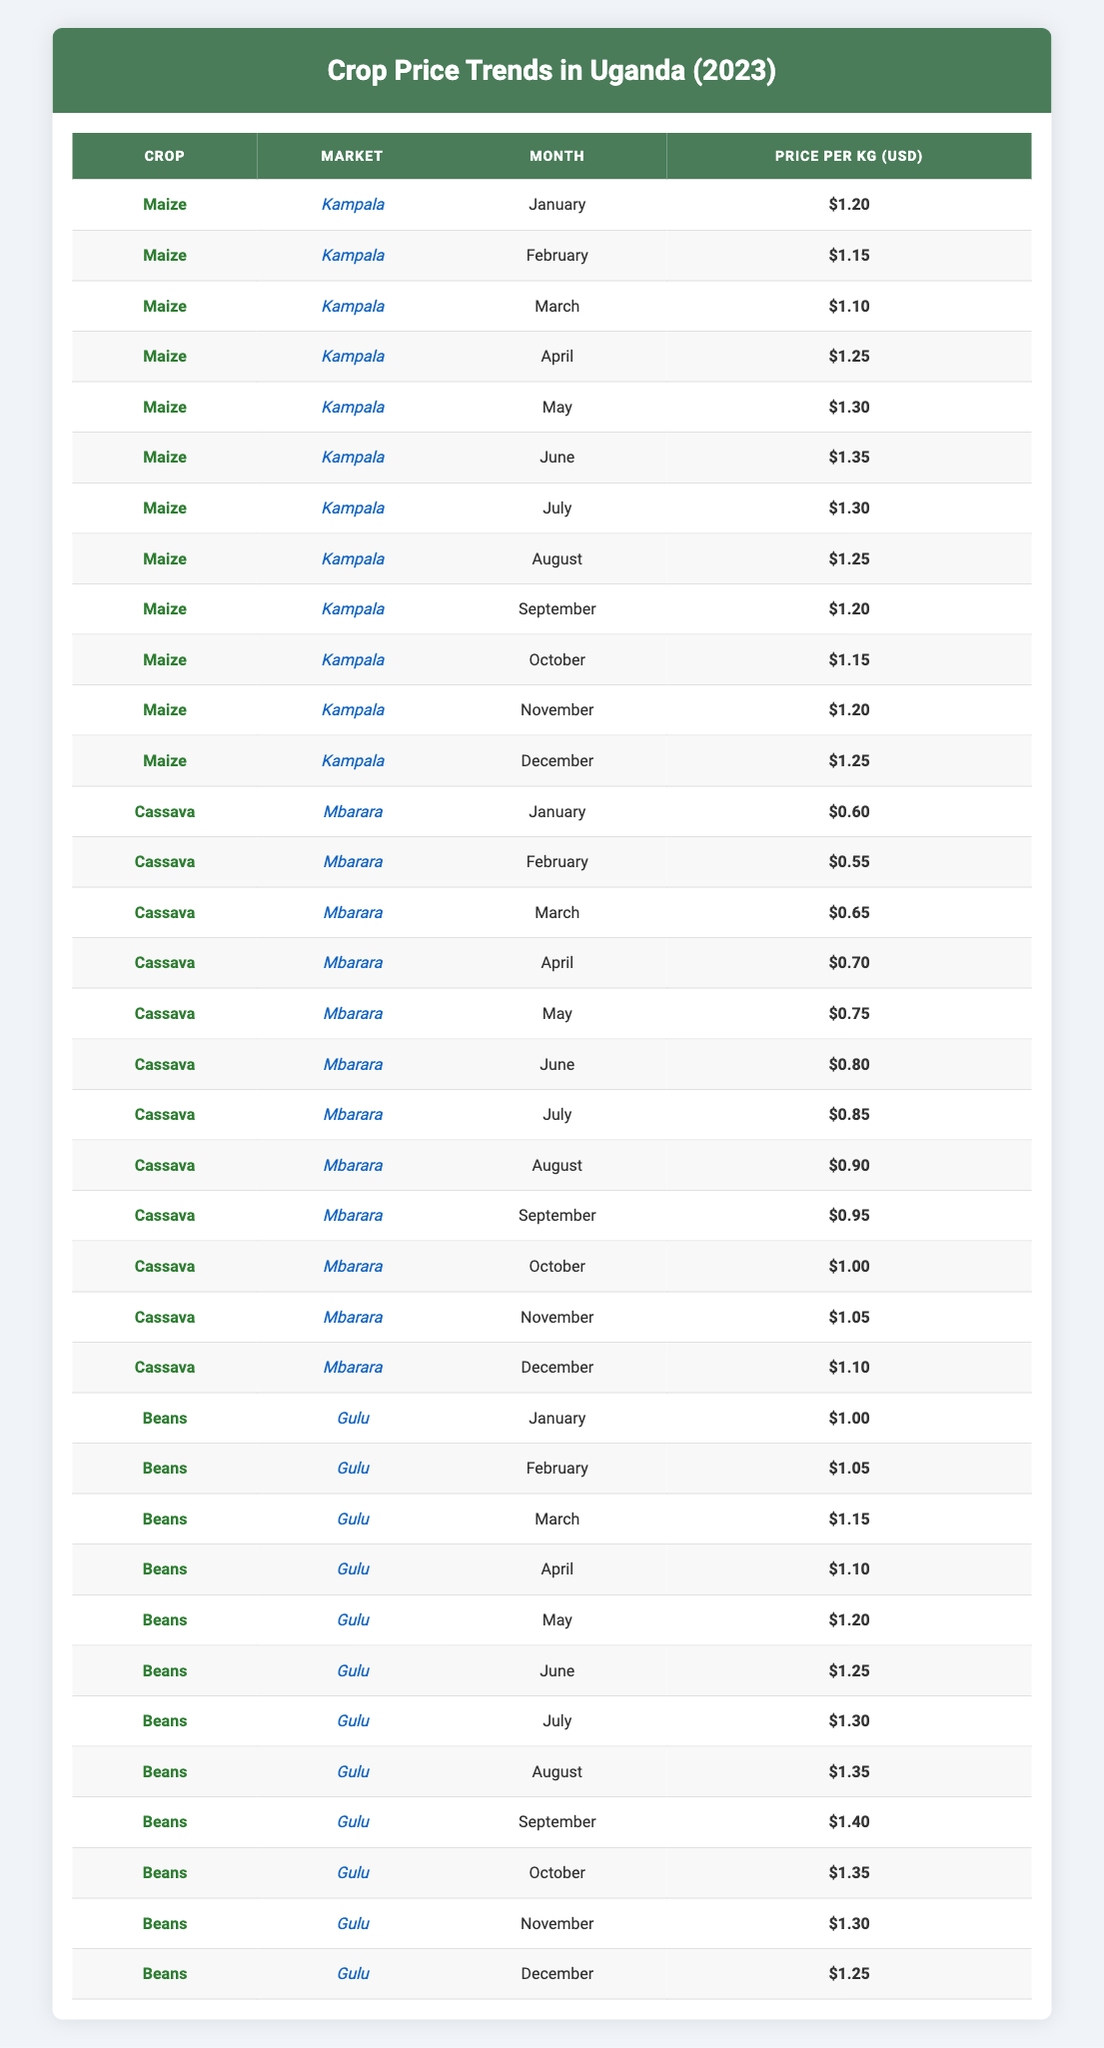What was the price of maize in Kampala in June? The table shows that the price of maize in Kampala in June is listed as $1.35.
Answer: $1.35 What is the average price of cassava sold in Mbarara from January to December? To calculate the average price, we first sum the prices from January ($0.60), February ($0.55), March ($0.65), April ($0.70), May ($0.75), June ($0.80), July ($0.85), August ($0.90), September ($0.95), October ($1.00), November ($1.05), and December ($1.10). The total sum is $0.60 + $0.55 + $0.65 + $0.70 + $0.75 + $0.80 + $0.85 + $0.90 + $0.95 + $1.00 + $1.05 + $1.10 = $11.60. There are 12 months in total, so the average is $11.60 / 12 = $0.9667 (approximately $0.97).
Answer: $0.97 Did the price of beans in Gulu ever reach $1.40? Yes, in September, the price of beans in Gulu reached $1.40.
Answer: Yes What was the highest price of maize in Kampala during the year? Looking through the prices listed for maize in Kampala, the highest price is $1.35, which occurred in June.
Answer: $1.35 In which month did the price of cassava see the largest increase from the previous month? By comparing each month's price with the previous month for cassava, we see that the largest increase occurred from July ($0.85) to August ($0.90), which is an increase of $0.05.
Answer: August What was the price trend for beans in Gulu from January to December? The price of beans started at $1.00 in January and increased gradually, reaching a peak of $1.40 in September. It then decreased back to $1.25 by December. The general trend indicates an increase followed by a slight decline in the last few months.
Answer: Increased then decreased What was the price difference between the highest and lowest price of cassava in Mbarara? The highest price for cassava was $1.10 in December, and the lowest price was $0.55 in February. The difference is calculated as $1.10 - $0.55 = $0.55.
Answer: $0.55 Is the average price of beans higher than the average price of maize in Kampala? First, we need to calculate the average prices: For beans: (1.00 + 1.05 + 1.15 + 1.10 + 1.20 + 1.25 + 1.30 + 1.35 + 1.40 + 1.35 + 1.30 + 1.25) / 12 = $1.225. For maize: (1.20 + 1.15 + 1.10 + 1.25 + 1.30 + 1.35 + 1.30 + 1.25 + 1.20 + 1.15 + 1.20 + 1.25) / 12 = $1.22. Here, $1.225 is slightly higher than $1.22, thus the average price of beans is indeed higher.
Answer: Yes What is the most stable price crop across all markets throughout the year? Analyzing each crop's prices across all months reveals that cassava shows the least fluctuation, as it has a consistent gradual increase with no sharp rises or falls.
Answer: Cassava 